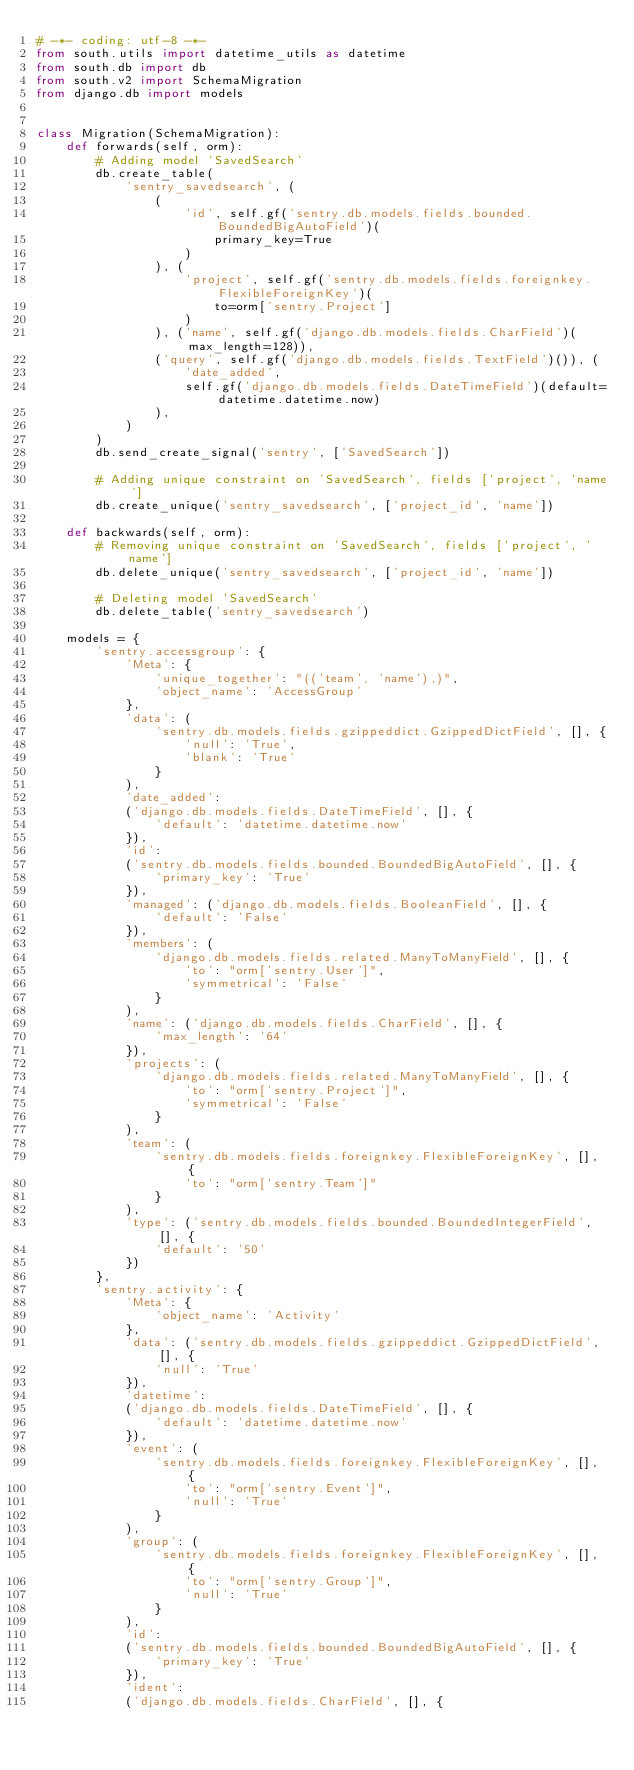<code> <loc_0><loc_0><loc_500><loc_500><_Python_># -*- coding: utf-8 -*-
from south.utils import datetime_utils as datetime
from south.db import db
from south.v2 import SchemaMigration
from django.db import models


class Migration(SchemaMigration):
    def forwards(self, orm):
        # Adding model 'SavedSearch'
        db.create_table(
            'sentry_savedsearch', (
                (
                    'id', self.gf('sentry.db.models.fields.bounded.BoundedBigAutoField')(
                        primary_key=True
                    )
                ), (
                    'project', self.gf('sentry.db.models.fields.foreignkey.FlexibleForeignKey')(
                        to=orm['sentry.Project']
                    )
                ), ('name', self.gf('django.db.models.fields.CharField')(max_length=128)),
                ('query', self.gf('django.db.models.fields.TextField')()), (
                    'date_added',
                    self.gf('django.db.models.fields.DateTimeField')(default=datetime.datetime.now)
                ),
            )
        )
        db.send_create_signal('sentry', ['SavedSearch'])

        # Adding unique constraint on 'SavedSearch', fields ['project', 'name']
        db.create_unique('sentry_savedsearch', ['project_id', 'name'])

    def backwards(self, orm):
        # Removing unique constraint on 'SavedSearch', fields ['project', 'name']
        db.delete_unique('sentry_savedsearch', ['project_id', 'name'])

        # Deleting model 'SavedSearch'
        db.delete_table('sentry_savedsearch')

    models = {
        'sentry.accessgroup': {
            'Meta': {
                'unique_together': "(('team', 'name'),)",
                'object_name': 'AccessGroup'
            },
            'data': (
                'sentry.db.models.fields.gzippeddict.GzippedDictField', [], {
                    'null': 'True',
                    'blank': 'True'
                }
            ),
            'date_added':
            ('django.db.models.fields.DateTimeField', [], {
                'default': 'datetime.datetime.now'
            }),
            'id':
            ('sentry.db.models.fields.bounded.BoundedBigAutoField', [], {
                'primary_key': 'True'
            }),
            'managed': ('django.db.models.fields.BooleanField', [], {
                'default': 'False'
            }),
            'members': (
                'django.db.models.fields.related.ManyToManyField', [], {
                    'to': "orm['sentry.User']",
                    'symmetrical': 'False'
                }
            ),
            'name': ('django.db.models.fields.CharField', [], {
                'max_length': '64'
            }),
            'projects': (
                'django.db.models.fields.related.ManyToManyField', [], {
                    'to': "orm['sentry.Project']",
                    'symmetrical': 'False'
                }
            ),
            'team': (
                'sentry.db.models.fields.foreignkey.FlexibleForeignKey', [], {
                    'to': "orm['sentry.Team']"
                }
            ),
            'type': ('sentry.db.models.fields.bounded.BoundedIntegerField', [], {
                'default': '50'
            })
        },
        'sentry.activity': {
            'Meta': {
                'object_name': 'Activity'
            },
            'data': ('sentry.db.models.fields.gzippeddict.GzippedDictField', [], {
                'null': 'True'
            }),
            'datetime':
            ('django.db.models.fields.DateTimeField', [], {
                'default': 'datetime.datetime.now'
            }),
            'event': (
                'sentry.db.models.fields.foreignkey.FlexibleForeignKey', [], {
                    'to': "orm['sentry.Event']",
                    'null': 'True'
                }
            ),
            'group': (
                'sentry.db.models.fields.foreignkey.FlexibleForeignKey', [], {
                    'to': "orm['sentry.Group']",
                    'null': 'True'
                }
            ),
            'id':
            ('sentry.db.models.fields.bounded.BoundedBigAutoField', [], {
                'primary_key': 'True'
            }),
            'ident':
            ('django.db.models.fields.CharField', [], {</code> 